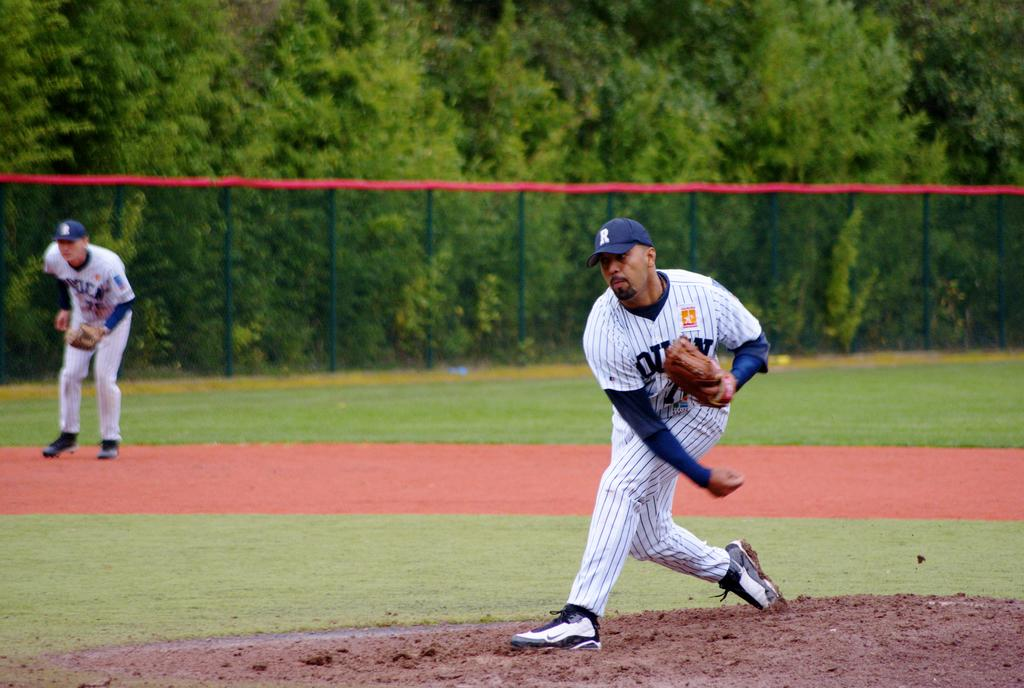<image>
Summarize the visual content of the image. A baseball player with the letter R on his hat pitches the ball. 